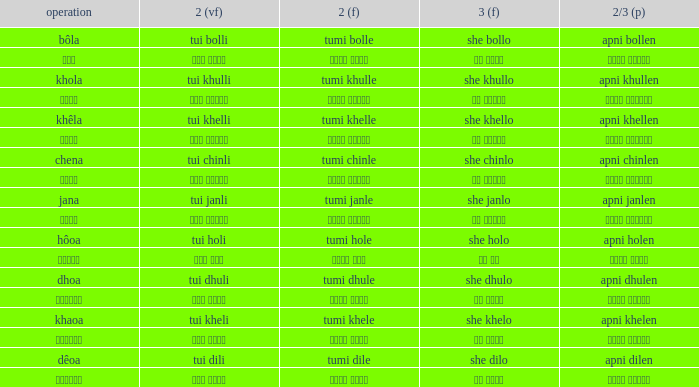What is the verb for Khola? She khullo. 